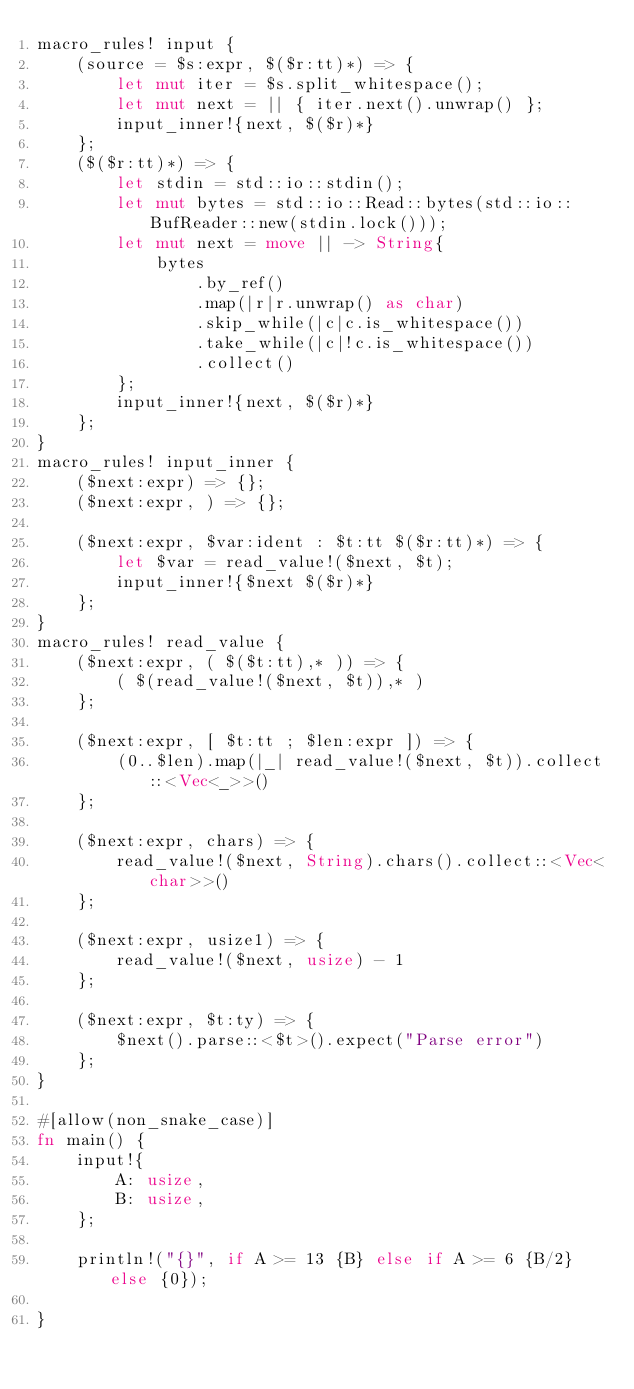<code> <loc_0><loc_0><loc_500><loc_500><_Rust_>macro_rules! input {
    (source = $s:expr, $($r:tt)*) => {
        let mut iter = $s.split_whitespace();
        let mut next = || { iter.next().unwrap() };
        input_inner!{next, $($r)*}
    };
    ($($r:tt)*) => {
        let stdin = std::io::stdin();
        let mut bytes = std::io::Read::bytes(std::io::BufReader::new(stdin.lock()));
        let mut next = move || -> String{
            bytes
                .by_ref()
                .map(|r|r.unwrap() as char)
                .skip_while(|c|c.is_whitespace())
                .take_while(|c|!c.is_whitespace())
                .collect()
        };
        input_inner!{next, $($r)*}
    };
}
macro_rules! input_inner {
    ($next:expr) => {};
    ($next:expr, ) => {};

    ($next:expr, $var:ident : $t:tt $($r:tt)*) => {
        let $var = read_value!($next, $t);
        input_inner!{$next $($r)*}
    };
}
macro_rules! read_value {
    ($next:expr, ( $($t:tt),* )) => {
        ( $(read_value!($next, $t)),* )
    };

    ($next:expr, [ $t:tt ; $len:expr ]) => {
        (0..$len).map(|_| read_value!($next, $t)).collect::<Vec<_>>()
    };

    ($next:expr, chars) => {
        read_value!($next, String).chars().collect::<Vec<char>>()
    };

    ($next:expr, usize1) => {
        read_value!($next, usize) - 1
    };

    ($next:expr, $t:ty) => {
        $next().parse::<$t>().expect("Parse error")
    };
}

#[allow(non_snake_case)]
fn main() {
    input!{
        A: usize,
        B: usize,
    };

    println!("{}", if A >= 13 {B} else if A >= 6 {B/2} else {0});

}

</code> 